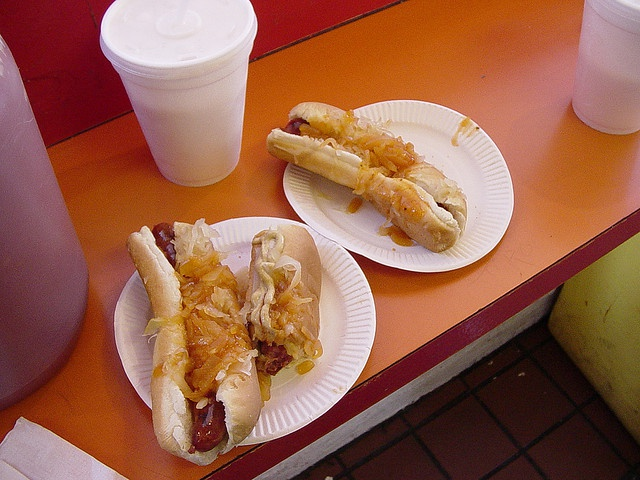Describe the objects in this image and their specific colors. I can see dining table in maroon, red, and lightgray tones, cup in maroon, lavender, darkgray, and brown tones, hot dog in maroon, red, and tan tones, hot dog in maroon, olive, and tan tones, and hot dog in maroon, olive, and tan tones in this image. 